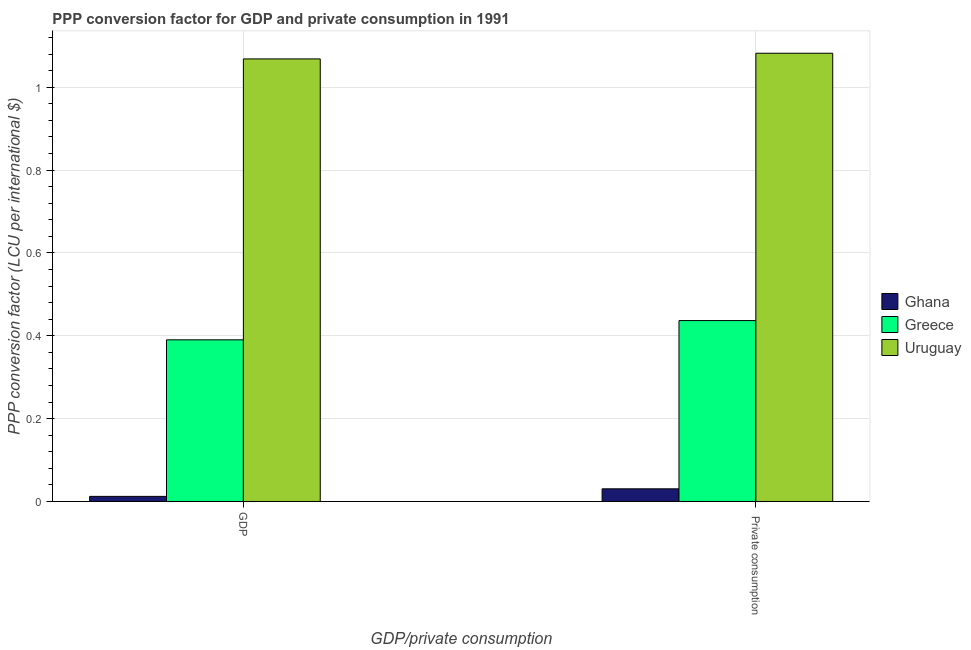Are the number of bars per tick equal to the number of legend labels?
Your response must be concise. Yes. Are the number of bars on each tick of the X-axis equal?
Provide a short and direct response. Yes. How many bars are there on the 1st tick from the left?
Your answer should be compact. 3. How many bars are there on the 1st tick from the right?
Offer a terse response. 3. What is the label of the 1st group of bars from the left?
Provide a succinct answer. GDP. What is the ppp conversion factor for gdp in Greece?
Offer a very short reply. 0.39. Across all countries, what is the maximum ppp conversion factor for gdp?
Your answer should be very brief. 1.07. Across all countries, what is the minimum ppp conversion factor for private consumption?
Keep it short and to the point. 0.03. In which country was the ppp conversion factor for gdp maximum?
Your answer should be very brief. Uruguay. What is the total ppp conversion factor for gdp in the graph?
Offer a terse response. 1.47. What is the difference between the ppp conversion factor for gdp in Greece and that in Ghana?
Provide a short and direct response. 0.38. What is the difference between the ppp conversion factor for gdp in Ghana and the ppp conversion factor for private consumption in Greece?
Make the answer very short. -0.42. What is the average ppp conversion factor for gdp per country?
Ensure brevity in your answer.  0.49. What is the difference between the ppp conversion factor for gdp and ppp conversion factor for private consumption in Uruguay?
Ensure brevity in your answer.  -0.01. In how many countries, is the ppp conversion factor for private consumption greater than 0.48000000000000004 LCU?
Ensure brevity in your answer.  1. What is the ratio of the ppp conversion factor for gdp in Greece to that in Ghana?
Provide a short and direct response. 31.74. In how many countries, is the ppp conversion factor for private consumption greater than the average ppp conversion factor for private consumption taken over all countries?
Keep it short and to the point. 1. What does the 1st bar from the left in GDP represents?
Offer a very short reply. Ghana. What does the 1st bar from the right in GDP represents?
Make the answer very short. Uruguay. How many bars are there?
Offer a very short reply. 6. Are all the bars in the graph horizontal?
Keep it short and to the point. No. Does the graph contain grids?
Provide a short and direct response. Yes. How are the legend labels stacked?
Offer a very short reply. Vertical. What is the title of the graph?
Your answer should be compact. PPP conversion factor for GDP and private consumption in 1991. What is the label or title of the X-axis?
Offer a very short reply. GDP/private consumption. What is the label or title of the Y-axis?
Offer a terse response. PPP conversion factor (LCU per international $). What is the PPP conversion factor (LCU per international $) of Ghana in GDP?
Your answer should be very brief. 0.01. What is the PPP conversion factor (LCU per international $) in Greece in GDP?
Provide a short and direct response. 0.39. What is the PPP conversion factor (LCU per international $) of Uruguay in GDP?
Make the answer very short. 1.07. What is the PPP conversion factor (LCU per international $) in Ghana in  Private consumption?
Ensure brevity in your answer.  0.03. What is the PPP conversion factor (LCU per international $) of Greece in  Private consumption?
Your answer should be compact. 0.44. What is the PPP conversion factor (LCU per international $) of Uruguay in  Private consumption?
Provide a short and direct response. 1.08. Across all GDP/private consumption, what is the maximum PPP conversion factor (LCU per international $) of Ghana?
Your answer should be very brief. 0.03. Across all GDP/private consumption, what is the maximum PPP conversion factor (LCU per international $) in Greece?
Offer a very short reply. 0.44. Across all GDP/private consumption, what is the maximum PPP conversion factor (LCU per international $) of Uruguay?
Make the answer very short. 1.08. Across all GDP/private consumption, what is the minimum PPP conversion factor (LCU per international $) of Ghana?
Give a very brief answer. 0.01. Across all GDP/private consumption, what is the minimum PPP conversion factor (LCU per international $) of Greece?
Provide a succinct answer. 0.39. Across all GDP/private consumption, what is the minimum PPP conversion factor (LCU per international $) of Uruguay?
Your response must be concise. 1.07. What is the total PPP conversion factor (LCU per international $) of Ghana in the graph?
Ensure brevity in your answer.  0.04. What is the total PPP conversion factor (LCU per international $) of Greece in the graph?
Your response must be concise. 0.83. What is the total PPP conversion factor (LCU per international $) of Uruguay in the graph?
Ensure brevity in your answer.  2.15. What is the difference between the PPP conversion factor (LCU per international $) in Ghana in GDP and that in  Private consumption?
Make the answer very short. -0.02. What is the difference between the PPP conversion factor (LCU per international $) of Greece in GDP and that in  Private consumption?
Make the answer very short. -0.05. What is the difference between the PPP conversion factor (LCU per international $) of Uruguay in GDP and that in  Private consumption?
Your answer should be very brief. -0.01. What is the difference between the PPP conversion factor (LCU per international $) in Ghana in GDP and the PPP conversion factor (LCU per international $) in Greece in  Private consumption?
Your response must be concise. -0.42. What is the difference between the PPP conversion factor (LCU per international $) of Ghana in GDP and the PPP conversion factor (LCU per international $) of Uruguay in  Private consumption?
Provide a succinct answer. -1.07. What is the difference between the PPP conversion factor (LCU per international $) in Greece in GDP and the PPP conversion factor (LCU per international $) in Uruguay in  Private consumption?
Offer a very short reply. -0.69. What is the average PPP conversion factor (LCU per international $) in Ghana per GDP/private consumption?
Offer a very short reply. 0.02. What is the average PPP conversion factor (LCU per international $) in Greece per GDP/private consumption?
Offer a very short reply. 0.41. What is the average PPP conversion factor (LCU per international $) of Uruguay per GDP/private consumption?
Your answer should be very brief. 1.08. What is the difference between the PPP conversion factor (LCU per international $) of Ghana and PPP conversion factor (LCU per international $) of Greece in GDP?
Keep it short and to the point. -0.38. What is the difference between the PPP conversion factor (LCU per international $) of Ghana and PPP conversion factor (LCU per international $) of Uruguay in GDP?
Keep it short and to the point. -1.06. What is the difference between the PPP conversion factor (LCU per international $) in Greece and PPP conversion factor (LCU per international $) in Uruguay in GDP?
Provide a short and direct response. -0.68. What is the difference between the PPP conversion factor (LCU per international $) in Ghana and PPP conversion factor (LCU per international $) in Greece in  Private consumption?
Give a very brief answer. -0.41. What is the difference between the PPP conversion factor (LCU per international $) in Ghana and PPP conversion factor (LCU per international $) in Uruguay in  Private consumption?
Your response must be concise. -1.05. What is the difference between the PPP conversion factor (LCU per international $) of Greece and PPP conversion factor (LCU per international $) of Uruguay in  Private consumption?
Your answer should be compact. -0.65. What is the ratio of the PPP conversion factor (LCU per international $) of Ghana in GDP to that in  Private consumption?
Offer a terse response. 0.4. What is the ratio of the PPP conversion factor (LCU per international $) of Greece in GDP to that in  Private consumption?
Make the answer very short. 0.89. What is the ratio of the PPP conversion factor (LCU per international $) of Uruguay in GDP to that in  Private consumption?
Your answer should be compact. 0.99. What is the difference between the highest and the second highest PPP conversion factor (LCU per international $) of Ghana?
Give a very brief answer. 0.02. What is the difference between the highest and the second highest PPP conversion factor (LCU per international $) of Greece?
Offer a very short reply. 0.05. What is the difference between the highest and the second highest PPP conversion factor (LCU per international $) in Uruguay?
Your answer should be very brief. 0.01. What is the difference between the highest and the lowest PPP conversion factor (LCU per international $) in Ghana?
Your answer should be very brief. 0.02. What is the difference between the highest and the lowest PPP conversion factor (LCU per international $) in Greece?
Provide a short and direct response. 0.05. What is the difference between the highest and the lowest PPP conversion factor (LCU per international $) in Uruguay?
Keep it short and to the point. 0.01. 